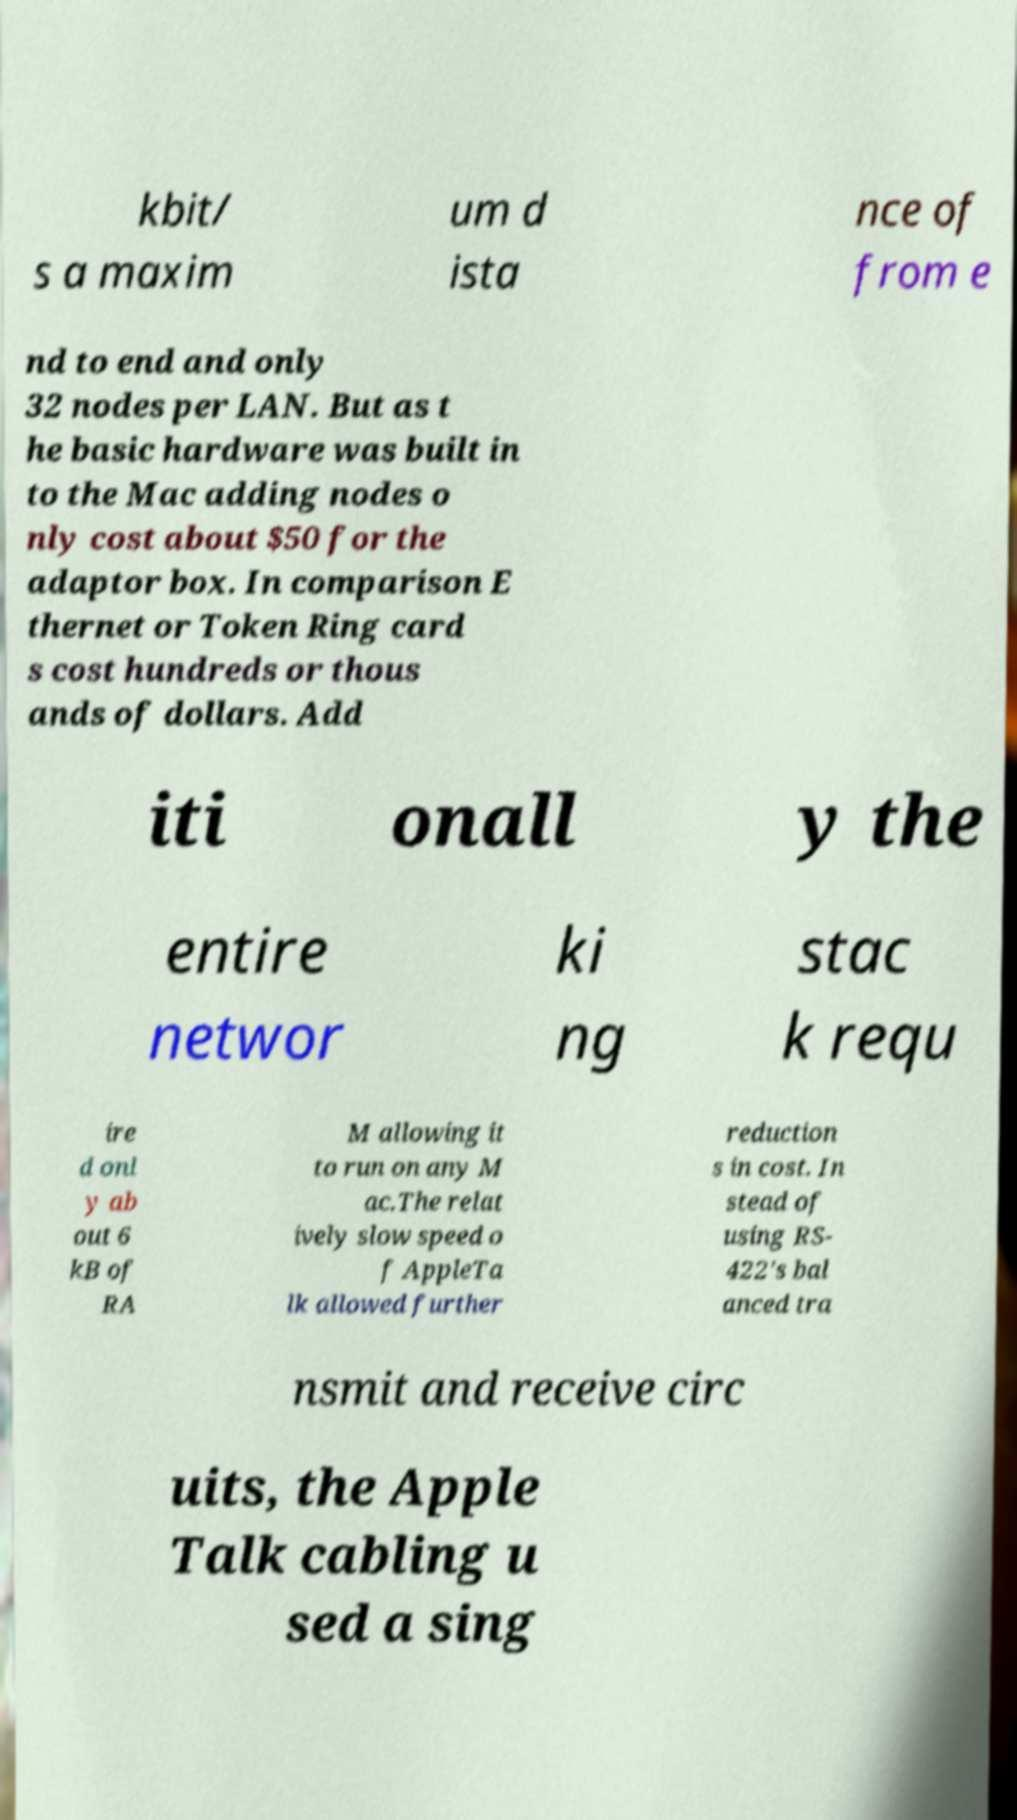Could you extract and type out the text from this image? kbit/ s a maxim um d ista nce of from e nd to end and only 32 nodes per LAN. But as t he basic hardware was built in to the Mac adding nodes o nly cost about $50 for the adaptor box. In comparison E thernet or Token Ring card s cost hundreds or thous ands of dollars. Add iti onall y the entire networ ki ng stac k requ ire d onl y ab out 6 kB of RA M allowing it to run on any M ac.The relat ively slow speed o f AppleTa lk allowed further reduction s in cost. In stead of using RS- 422's bal anced tra nsmit and receive circ uits, the Apple Talk cabling u sed a sing 